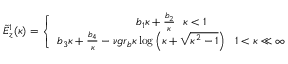<formula> <loc_0><loc_0><loc_500><loc_500>\begin{array} { r } { \tilde { E } _ { z } ^ { 1 } ( \kappa ) = \left \{ \begin{array} { c } { b _ { 1 } \kappa + \frac { b _ { 2 } } { \kappa } \kappa < 1 } \\ { b _ { 3 } \kappa + \frac { b _ { 4 } } { \kappa } - \nu g r _ { b } \kappa \log \left ( \kappa + \sqrt { \kappa ^ { 2 } - 1 } \right ) 1 < \kappa \ll \infty } \end{array} } \end{array}</formula> 